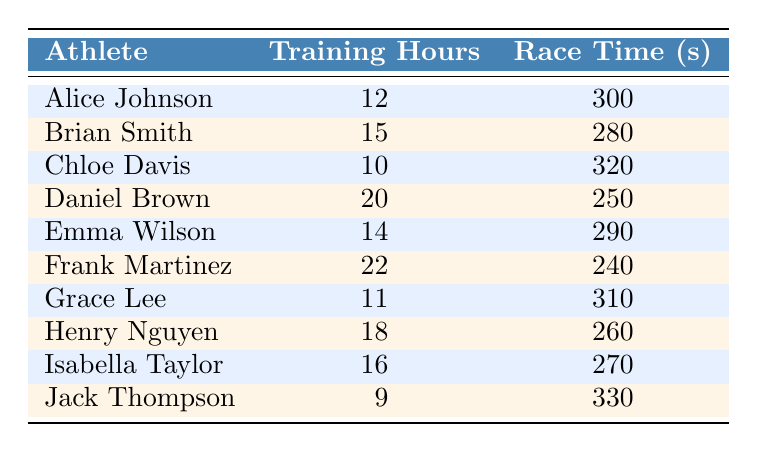What is the race performance time of Daniel Brown? Looking at the table, I find that Daniel Brown has a race performance time of 250 seconds.
Answer: 250 seconds How many training hours did Frank Martinez have? Referring directly to the table, I see Frank Martinez trained for 22 hours.
Answer: 22 hours Which athlete had the shortest race performance time? Scanning through the race performance times, Frank Martinez with 240 seconds had the shortest time compared to others.
Answer: Frank Martinez Is it true that Brian Smith trained more hours than Emma Wilson? In the table, Brian Smith has 15 training hours and Emma Wilson has 14 training hours, so it is true that Brian Smith trained more hours.
Answer: Yes What is the average training hours for the athletes? To calculate the average, I sum the training hours: 12 + 15 + 10 + 20 + 14 + 22 + 11 + 18 + 16 + 9 =  9+10+11+12+14+15+16+18+20+22 = 12.7 training hours, with 10 athletes, the average is (12 + 15 + 10 + 20 + 14 + 22 + 11 + 18 + 16 + 9) / 10 = 15.7.
Answer: 15.7 training hours What is the total race performance time of all athletes? Adding all race times together: 300 + 280 + 320 + 250 + 290 + 240 + 310 + 260 + 270 + 330 = 2650 seconds.
Answer: 2650 seconds How many athletes trained for more than 15 hours? Looking at the table, the athletes that trained for more than 15 hours are Brian Smith, Daniel Brown, Frank Martinez, Henry Nguyen, and Isabella Taylor which totals to 5 athletes.
Answer: 5 athletes What is the difference in race performance time between Alice Johnson and Chloe Davis? Alice Johnson has a time of 300 seconds and Chloe Davis has a time of 320 seconds. So, the difference is 320 - 300 = 20 seconds.
Answer: 20 seconds List the athletes who trained for less than 12 hours. Scanning the table, I see that athletes who trained for less than 12 hours are Chloe Davis (10 hours) and Jack Thompson (9 hours), totaling 2 athletes.
Answer: Chloe Davis and Jack Thompson 